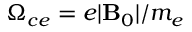Convert formula to latex. <formula><loc_0><loc_0><loc_500><loc_500>{ \Omega _ { c e } = e | \mathbf B _ { 0 } | / m _ { e } }</formula> 